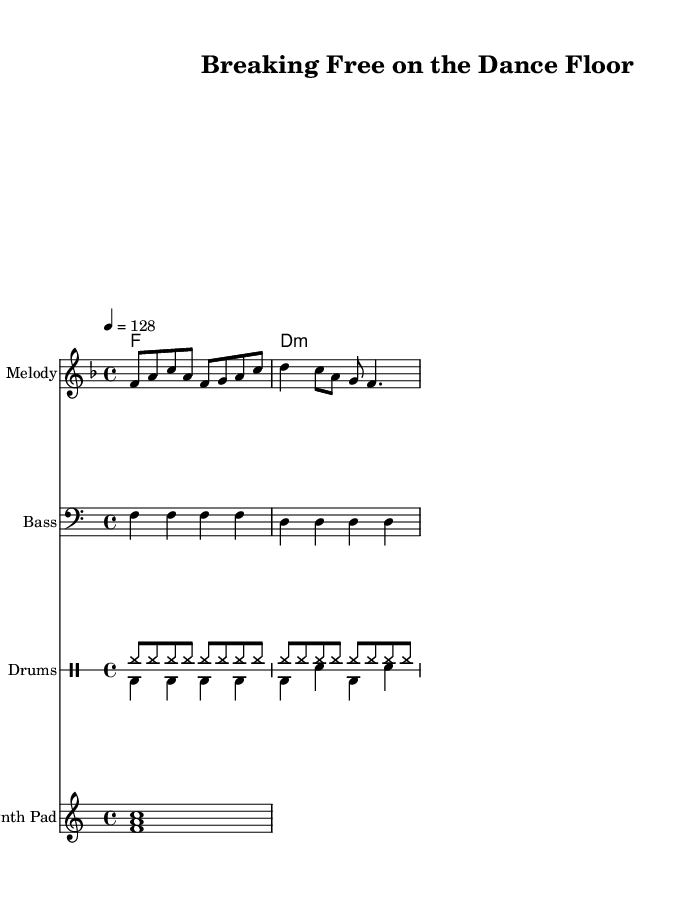What is the key signature of this music? The key signature is F major, which contains one flat (B flat). This is indicated at the beginning of the score.
Answer: F major What is the time signature of this piece? The time signature is 4/4, which shows there are four beats in a measure and the quarter note receives one beat. This can be seen at the beginning of the sheet music.
Answer: 4/4 What is the tempo marking for this composition? The tempo marking is 128 beats per minute, shown in the tempo indication at the start of the score, specifically noting the speed of the music.
Answer: 128 How many measures are shown in the melody section? The melody section consists of two measures; this can be counted directly from the notated notes which group into measures.
Answer: 2 Which chords are used in the harmony section? The harmony section features an F major chord and a D minor chord, indicated in the chord changes written above the staff.
Answer: F major, D minor What type of percussion is indicated in the drum part? The drum part includes hi-hats and bass drum, as shown in the specific notation marks for each drum type in the drum staff.
Answer: Hi-hats, bass drum What is the primary rhythmic feel of this piece? The primary rhythmic feel is upbeat and danceable, with strong accents on the multiple hi-hat hits and a consistent bass drum rhythm, typical of energetic house music.
Answer: Upbeat 